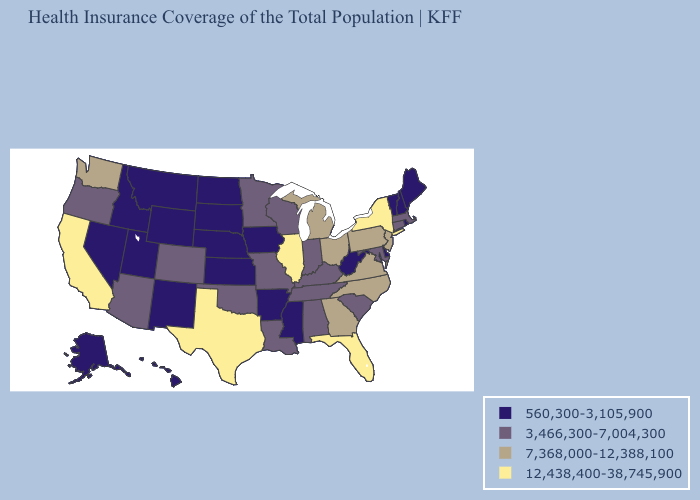What is the value of New Mexico?
Answer briefly. 560,300-3,105,900. Name the states that have a value in the range 3,466,300-7,004,300?
Quick response, please. Alabama, Arizona, Colorado, Connecticut, Indiana, Kentucky, Louisiana, Maryland, Massachusetts, Minnesota, Missouri, Oklahoma, Oregon, South Carolina, Tennessee, Wisconsin. Name the states that have a value in the range 7,368,000-12,388,100?
Answer briefly. Georgia, Michigan, New Jersey, North Carolina, Ohio, Pennsylvania, Virginia, Washington. Name the states that have a value in the range 560,300-3,105,900?
Quick response, please. Alaska, Arkansas, Delaware, Hawaii, Idaho, Iowa, Kansas, Maine, Mississippi, Montana, Nebraska, Nevada, New Hampshire, New Mexico, North Dakota, Rhode Island, South Dakota, Utah, Vermont, West Virginia, Wyoming. Name the states that have a value in the range 560,300-3,105,900?
Answer briefly. Alaska, Arkansas, Delaware, Hawaii, Idaho, Iowa, Kansas, Maine, Mississippi, Montana, Nebraska, Nevada, New Hampshire, New Mexico, North Dakota, Rhode Island, South Dakota, Utah, Vermont, West Virginia, Wyoming. Does Missouri have the highest value in the MidWest?
Keep it brief. No. What is the lowest value in the MidWest?
Give a very brief answer. 560,300-3,105,900. Name the states that have a value in the range 560,300-3,105,900?
Quick response, please. Alaska, Arkansas, Delaware, Hawaii, Idaho, Iowa, Kansas, Maine, Mississippi, Montana, Nebraska, Nevada, New Hampshire, New Mexico, North Dakota, Rhode Island, South Dakota, Utah, Vermont, West Virginia, Wyoming. Among the states that border South Dakota , which have the highest value?
Write a very short answer. Minnesota. Name the states that have a value in the range 3,466,300-7,004,300?
Answer briefly. Alabama, Arizona, Colorado, Connecticut, Indiana, Kentucky, Louisiana, Maryland, Massachusetts, Minnesota, Missouri, Oklahoma, Oregon, South Carolina, Tennessee, Wisconsin. What is the value of Wyoming?
Give a very brief answer. 560,300-3,105,900. Does the map have missing data?
Answer briefly. No. Which states hav the highest value in the South?
Quick response, please. Florida, Texas. What is the value of Wyoming?
Answer briefly. 560,300-3,105,900. Name the states that have a value in the range 560,300-3,105,900?
Give a very brief answer. Alaska, Arkansas, Delaware, Hawaii, Idaho, Iowa, Kansas, Maine, Mississippi, Montana, Nebraska, Nevada, New Hampshire, New Mexico, North Dakota, Rhode Island, South Dakota, Utah, Vermont, West Virginia, Wyoming. 